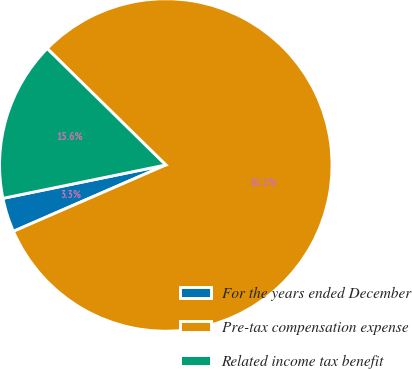Convert chart. <chart><loc_0><loc_0><loc_500><loc_500><pie_chart><fcel>For the years ended December<fcel>Pre-tax compensation expense<fcel>Related income tax benefit<nl><fcel>3.32%<fcel>81.11%<fcel>15.57%<nl></chart> 